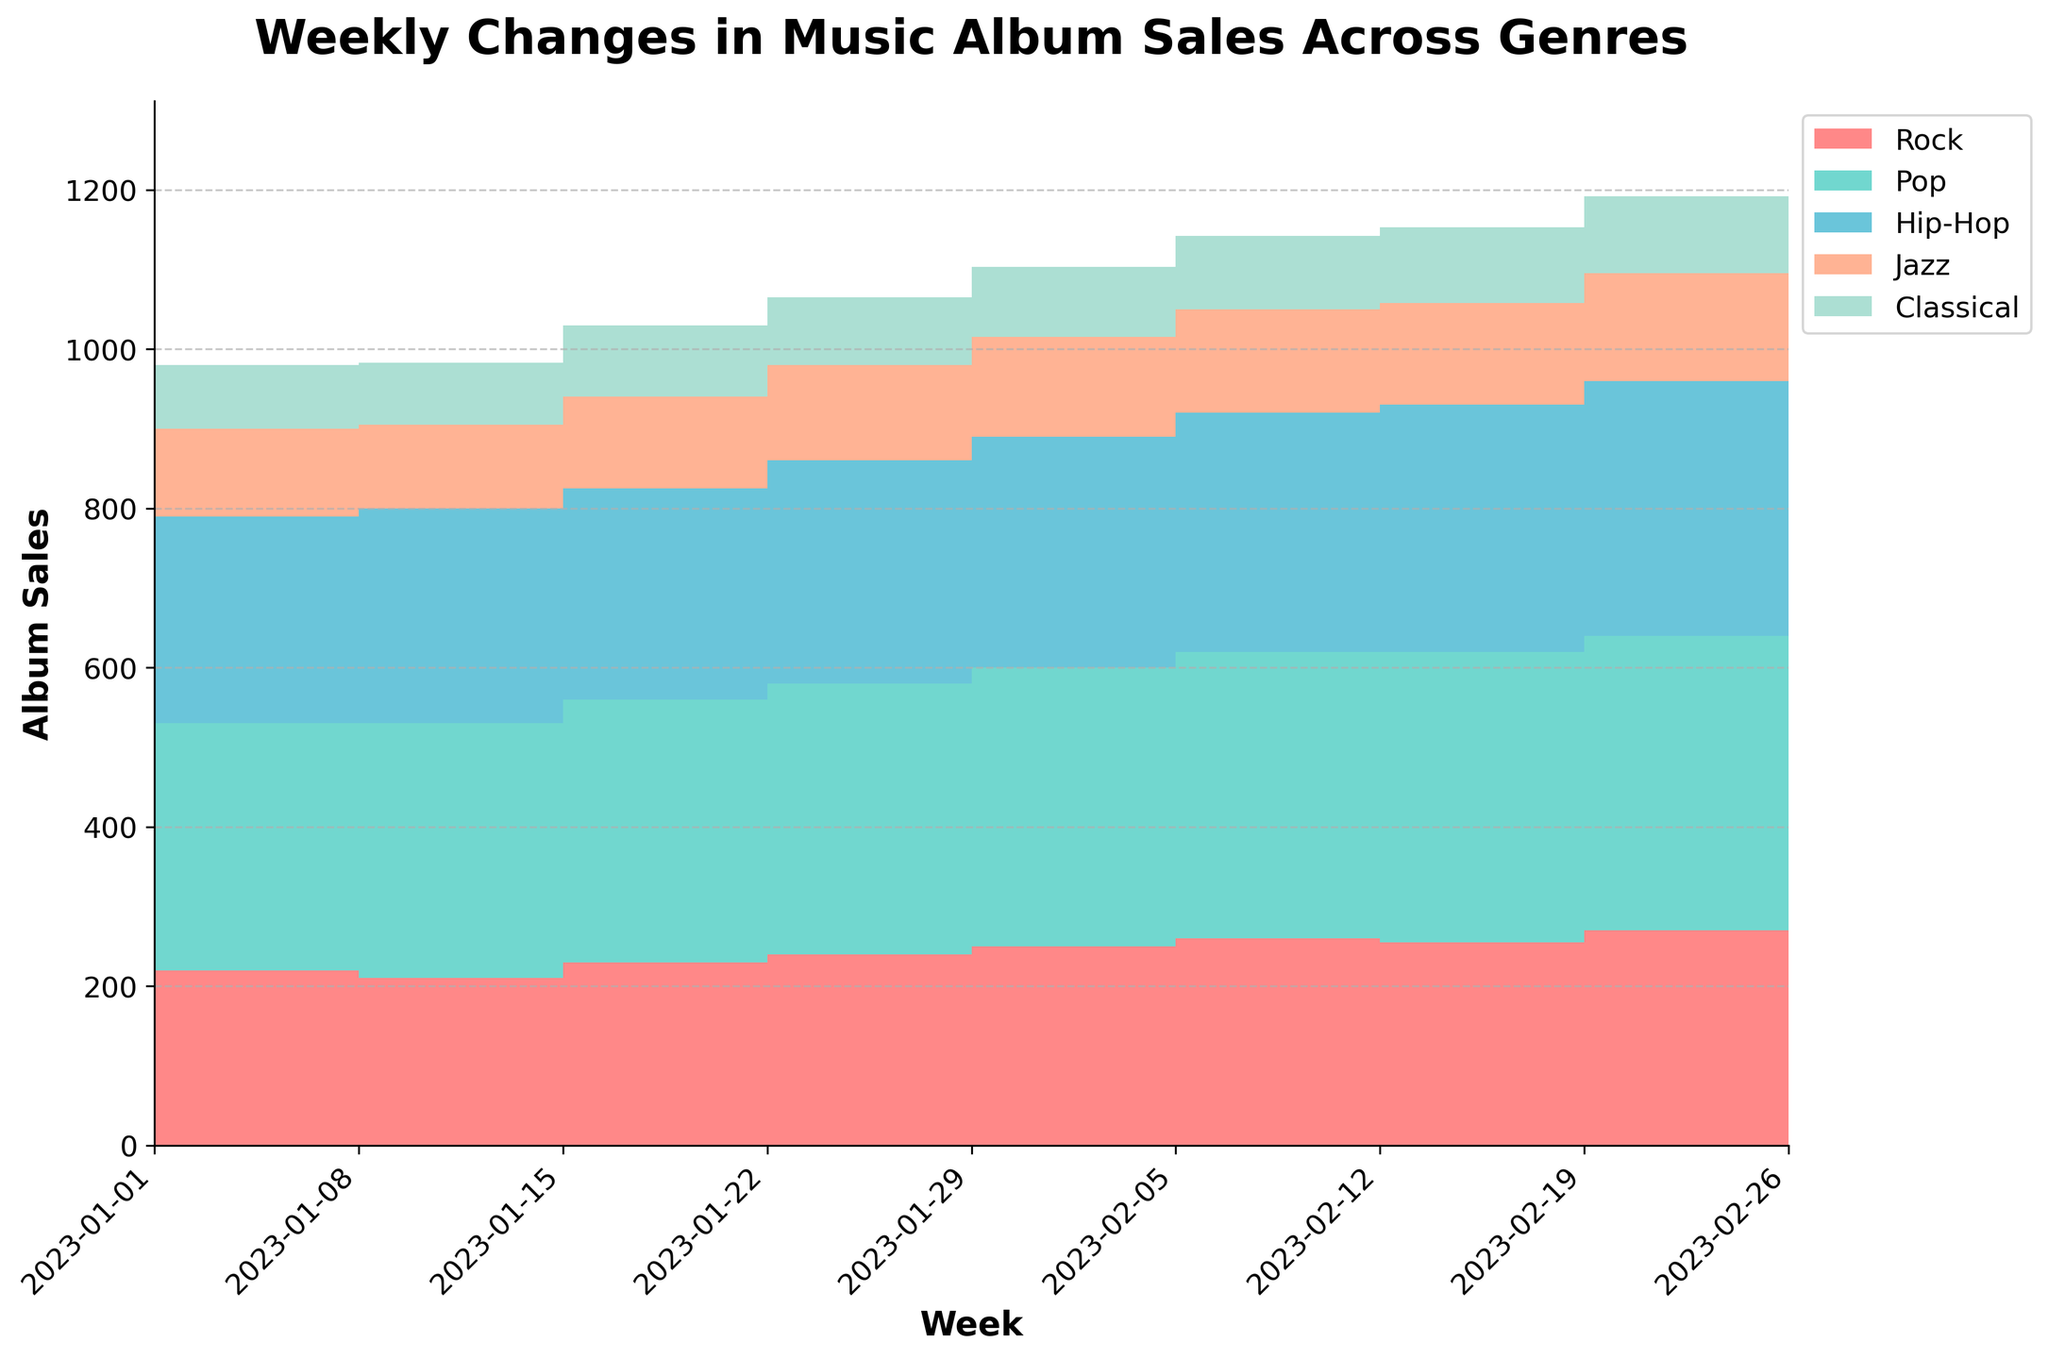What is the title of the chart? The title is located at the top center of the chart, and it summarizes the entire figure.
Answer: Weekly Changes in Music Album Sales Across Genres Which genre had the highest album sales in the first week? Look for the highest area in the stacked area part of the chart for the first week, which is around January 1st.
Answer: Pop What was the trend for Rock album sales over the weeks shown in the chart? Observe the orange-colored section (representing Rock) from the start to finish as it gradually increases.
Answer: Increasing How did Classical album sales change from the first week to the last week? Compare the height of the grey area (representing Classical) from January 1 to February 26.
Answer: Increased Compare the album sales trends between Jazz and Hip-Hop. Which genre saw a greater increase? Look at the relative heights of the purple shaded area (Jazz) and the green shaded area (Hip-Hop); Calculate their increases from the first week to the last.
Answer: Hip-Hop In which week did Pop albums reach the peak sales? Look for the week with the highest top of the green-colored area representing Pop in the chart.
Answer: Week starting 2023-02-26 Which genre had the smallest increase in album sales over the entire period? Compare the changes in heights for all the colored sections from the start week to end week; the smallest increase will be the Jazz section.
Answer: Jazz What are the units on the y-axis of the chart? Y-axis represents the number of album sales, typically showing the numbers for each genre.
Answer: Album Sales What is the total album sales for the week starting January 15, 2023? Sum up the heights of all stacked colored sections (Rock, Pop, Hip-Hop, Jazz, Classical) for the week of January 15.
Answer: 983 Which two genres had the closest album sales in the week of February 19, 2023? Compare the areas of genres on February 19, identify the two with the smallest difference in height at that week.
Answer: Jazz and Classical 